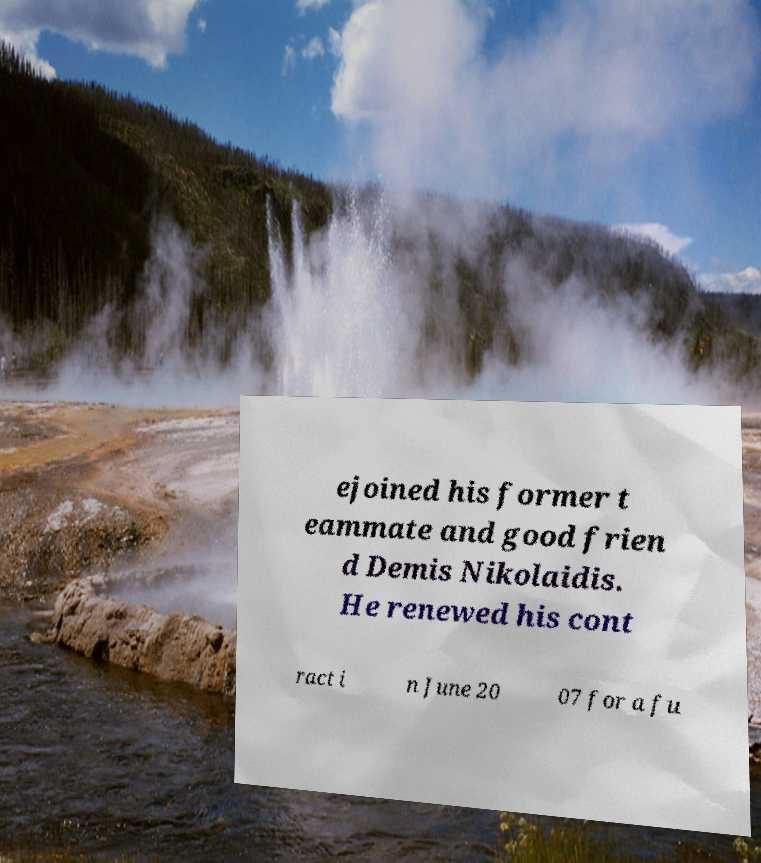Could you extract and type out the text from this image? ejoined his former t eammate and good frien d Demis Nikolaidis. He renewed his cont ract i n June 20 07 for a fu 